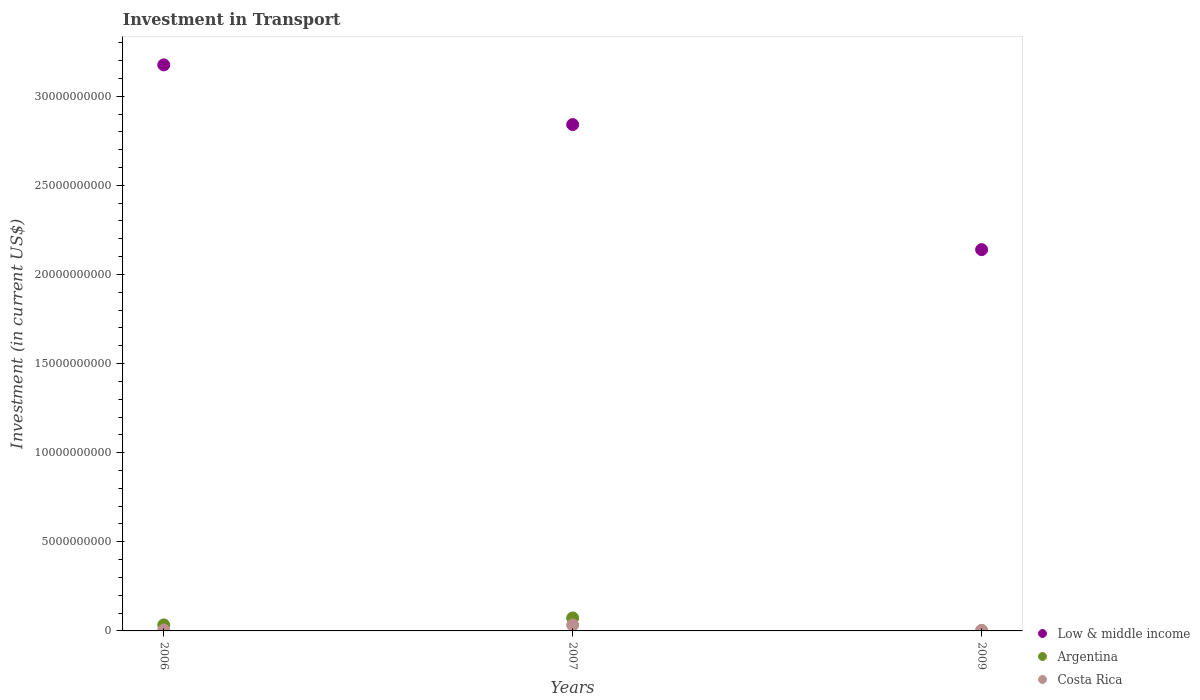How many different coloured dotlines are there?
Give a very brief answer. 3. Is the number of dotlines equal to the number of legend labels?
Provide a short and direct response. Yes. What is the amount invested in transport in Argentina in 2009?
Provide a succinct answer. 5.89e+06. Across all years, what is the maximum amount invested in transport in Costa Rica?
Give a very brief answer. 3.30e+08. Across all years, what is the minimum amount invested in transport in Low & middle income?
Ensure brevity in your answer.  2.14e+1. In which year was the amount invested in transport in Costa Rica maximum?
Provide a short and direct response. 2007. What is the total amount invested in transport in Argentina in the graph?
Give a very brief answer. 1.07e+09. What is the difference between the amount invested in transport in Argentina in 2006 and that in 2009?
Give a very brief answer. 3.31e+08. What is the difference between the amount invested in transport in Argentina in 2009 and the amount invested in transport in Low & middle income in 2007?
Provide a short and direct response. -2.84e+1. What is the average amount invested in transport in Costa Rica per year?
Your answer should be very brief. 1.36e+08. In the year 2007, what is the difference between the amount invested in transport in Argentina and amount invested in transport in Low & middle income?
Keep it short and to the point. -2.77e+1. In how many years, is the amount invested in transport in Argentina greater than 32000000000 US$?
Keep it short and to the point. 0. What is the ratio of the amount invested in transport in Low & middle income in 2006 to that in 2009?
Offer a terse response. 1.48. What is the difference between the highest and the second highest amount invested in transport in Costa Rica?
Ensure brevity in your answer.  2.87e+08. What is the difference between the highest and the lowest amount invested in transport in Argentina?
Keep it short and to the point. 7.23e+08. Is it the case that in every year, the sum of the amount invested in transport in Costa Rica and amount invested in transport in Low & middle income  is greater than the amount invested in transport in Argentina?
Your answer should be compact. Yes. Is the amount invested in transport in Costa Rica strictly greater than the amount invested in transport in Low & middle income over the years?
Your response must be concise. No. How many dotlines are there?
Keep it short and to the point. 3. Are the values on the major ticks of Y-axis written in scientific E-notation?
Your answer should be compact. No. Does the graph contain any zero values?
Provide a succinct answer. No. Where does the legend appear in the graph?
Provide a succinct answer. Bottom right. What is the title of the graph?
Your answer should be very brief. Investment in Transport. Does "Singapore" appear as one of the legend labels in the graph?
Keep it short and to the point. No. What is the label or title of the Y-axis?
Give a very brief answer. Investment (in current US$). What is the Investment (in current US$) in Low & middle income in 2006?
Your answer should be very brief. 3.18e+1. What is the Investment (in current US$) in Argentina in 2006?
Your answer should be very brief. 3.37e+08. What is the Investment (in current US$) of Costa Rica in 2006?
Your response must be concise. 4.30e+07. What is the Investment (in current US$) in Low & middle income in 2007?
Provide a succinct answer. 2.84e+1. What is the Investment (in current US$) of Argentina in 2007?
Provide a short and direct response. 7.29e+08. What is the Investment (in current US$) in Costa Rica in 2007?
Ensure brevity in your answer.  3.30e+08. What is the Investment (in current US$) in Low & middle income in 2009?
Provide a short and direct response. 2.14e+1. What is the Investment (in current US$) of Argentina in 2009?
Your response must be concise. 5.89e+06. What is the Investment (in current US$) in Costa Rica in 2009?
Your answer should be very brief. 3.40e+07. Across all years, what is the maximum Investment (in current US$) of Low & middle income?
Your answer should be compact. 3.18e+1. Across all years, what is the maximum Investment (in current US$) of Argentina?
Your response must be concise. 7.29e+08. Across all years, what is the maximum Investment (in current US$) in Costa Rica?
Your response must be concise. 3.30e+08. Across all years, what is the minimum Investment (in current US$) in Low & middle income?
Keep it short and to the point. 2.14e+1. Across all years, what is the minimum Investment (in current US$) of Argentina?
Provide a short and direct response. 5.89e+06. Across all years, what is the minimum Investment (in current US$) of Costa Rica?
Your response must be concise. 3.40e+07. What is the total Investment (in current US$) in Low & middle income in the graph?
Offer a very short reply. 8.16e+1. What is the total Investment (in current US$) of Argentina in the graph?
Offer a terse response. 1.07e+09. What is the total Investment (in current US$) in Costa Rica in the graph?
Your response must be concise. 4.07e+08. What is the difference between the Investment (in current US$) in Low & middle income in 2006 and that in 2007?
Your answer should be very brief. 3.35e+09. What is the difference between the Investment (in current US$) of Argentina in 2006 and that in 2007?
Make the answer very short. -3.92e+08. What is the difference between the Investment (in current US$) in Costa Rica in 2006 and that in 2007?
Offer a very short reply. -2.87e+08. What is the difference between the Investment (in current US$) in Low & middle income in 2006 and that in 2009?
Your answer should be compact. 1.04e+1. What is the difference between the Investment (in current US$) of Argentina in 2006 and that in 2009?
Keep it short and to the point. 3.31e+08. What is the difference between the Investment (in current US$) in Costa Rica in 2006 and that in 2009?
Make the answer very short. 9.00e+06. What is the difference between the Investment (in current US$) of Low & middle income in 2007 and that in 2009?
Keep it short and to the point. 7.02e+09. What is the difference between the Investment (in current US$) of Argentina in 2007 and that in 2009?
Keep it short and to the point. 7.23e+08. What is the difference between the Investment (in current US$) of Costa Rica in 2007 and that in 2009?
Give a very brief answer. 2.96e+08. What is the difference between the Investment (in current US$) of Low & middle income in 2006 and the Investment (in current US$) of Argentina in 2007?
Make the answer very short. 3.10e+1. What is the difference between the Investment (in current US$) of Low & middle income in 2006 and the Investment (in current US$) of Costa Rica in 2007?
Provide a succinct answer. 3.14e+1. What is the difference between the Investment (in current US$) in Low & middle income in 2006 and the Investment (in current US$) in Argentina in 2009?
Offer a terse response. 3.18e+1. What is the difference between the Investment (in current US$) of Low & middle income in 2006 and the Investment (in current US$) of Costa Rica in 2009?
Make the answer very short. 3.17e+1. What is the difference between the Investment (in current US$) in Argentina in 2006 and the Investment (in current US$) in Costa Rica in 2009?
Provide a succinct answer. 3.03e+08. What is the difference between the Investment (in current US$) in Low & middle income in 2007 and the Investment (in current US$) in Argentina in 2009?
Offer a terse response. 2.84e+1. What is the difference between the Investment (in current US$) of Low & middle income in 2007 and the Investment (in current US$) of Costa Rica in 2009?
Provide a short and direct response. 2.84e+1. What is the difference between the Investment (in current US$) of Argentina in 2007 and the Investment (in current US$) of Costa Rica in 2009?
Your answer should be very brief. 6.95e+08. What is the average Investment (in current US$) of Low & middle income per year?
Provide a short and direct response. 2.72e+1. What is the average Investment (in current US$) in Argentina per year?
Make the answer very short. 3.57e+08. What is the average Investment (in current US$) in Costa Rica per year?
Offer a terse response. 1.36e+08. In the year 2006, what is the difference between the Investment (in current US$) in Low & middle income and Investment (in current US$) in Argentina?
Keep it short and to the point. 3.14e+1. In the year 2006, what is the difference between the Investment (in current US$) of Low & middle income and Investment (in current US$) of Costa Rica?
Give a very brief answer. 3.17e+1. In the year 2006, what is the difference between the Investment (in current US$) in Argentina and Investment (in current US$) in Costa Rica?
Keep it short and to the point. 2.94e+08. In the year 2007, what is the difference between the Investment (in current US$) of Low & middle income and Investment (in current US$) of Argentina?
Provide a succinct answer. 2.77e+1. In the year 2007, what is the difference between the Investment (in current US$) of Low & middle income and Investment (in current US$) of Costa Rica?
Keep it short and to the point. 2.81e+1. In the year 2007, what is the difference between the Investment (in current US$) of Argentina and Investment (in current US$) of Costa Rica?
Offer a terse response. 3.99e+08. In the year 2009, what is the difference between the Investment (in current US$) in Low & middle income and Investment (in current US$) in Argentina?
Your answer should be very brief. 2.14e+1. In the year 2009, what is the difference between the Investment (in current US$) of Low & middle income and Investment (in current US$) of Costa Rica?
Give a very brief answer. 2.14e+1. In the year 2009, what is the difference between the Investment (in current US$) of Argentina and Investment (in current US$) of Costa Rica?
Offer a very short reply. -2.81e+07. What is the ratio of the Investment (in current US$) in Low & middle income in 2006 to that in 2007?
Ensure brevity in your answer.  1.12. What is the ratio of the Investment (in current US$) of Argentina in 2006 to that in 2007?
Provide a short and direct response. 0.46. What is the ratio of the Investment (in current US$) in Costa Rica in 2006 to that in 2007?
Give a very brief answer. 0.13. What is the ratio of the Investment (in current US$) in Low & middle income in 2006 to that in 2009?
Give a very brief answer. 1.48. What is the ratio of the Investment (in current US$) in Argentina in 2006 to that in 2009?
Your response must be concise. 57.22. What is the ratio of the Investment (in current US$) of Costa Rica in 2006 to that in 2009?
Ensure brevity in your answer.  1.26. What is the ratio of the Investment (in current US$) in Low & middle income in 2007 to that in 2009?
Give a very brief answer. 1.33. What is the ratio of the Investment (in current US$) of Argentina in 2007 to that in 2009?
Provide a succinct answer. 123.72. What is the ratio of the Investment (in current US$) in Costa Rica in 2007 to that in 2009?
Offer a terse response. 9.71. What is the difference between the highest and the second highest Investment (in current US$) in Low & middle income?
Keep it short and to the point. 3.35e+09. What is the difference between the highest and the second highest Investment (in current US$) in Argentina?
Give a very brief answer. 3.92e+08. What is the difference between the highest and the second highest Investment (in current US$) of Costa Rica?
Your answer should be compact. 2.87e+08. What is the difference between the highest and the lowest Investment (in current US$) in Low & middle income?
Offer a terse response. 1.04e+1. What is the difference between the highest and the lowest Investment (in current US$) in Argentina?
Provide a succinct answer. 7.23e+08. What is the difference between the highest and the lowest Investment (in current US$) of Costa Rica?
Offer a very short reply. 2.96e+08. 